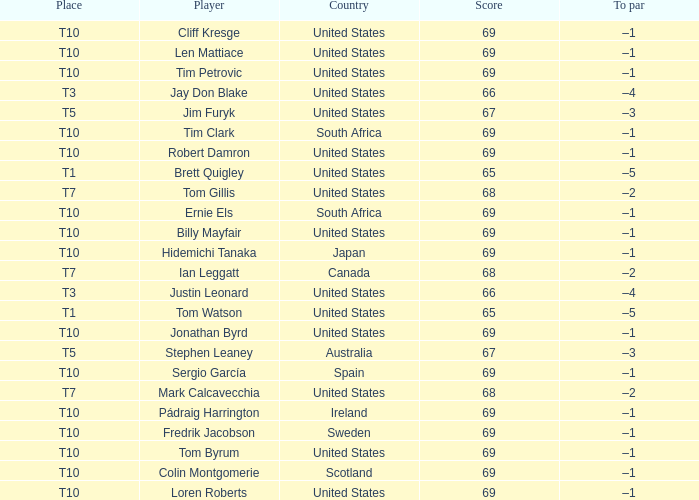Which country has is Len Mattiace in T10 place? United States. 